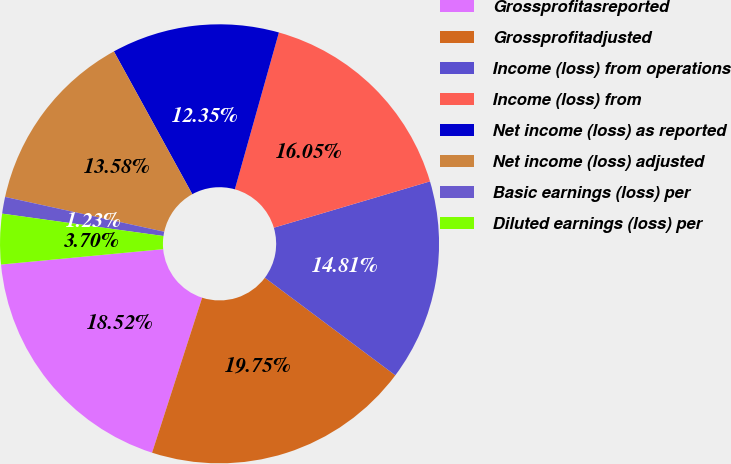Convert chart to OTSL. <chart><loc_0><loc_0><loc_500><loc_500><pie_chart><fcel>Grossprofitasreported<fcel>Grossprofitadjusted<fcel>Income (loss) from operations<fcel>Income (loss) from<fcel>Net income (loss) as reported<fcel>Net income (loss) adjusted<fcel>Basic earnings (loss) per<fcel>Diluted earnings (loss) per<nl><fcel>18.52%<fcel>19.75%<fcel>14.81%<fcel>16.05%<fcel>12.35%<fcel>13.58%<fcel>1.23%<fcel>3.7%<nl></chart> 